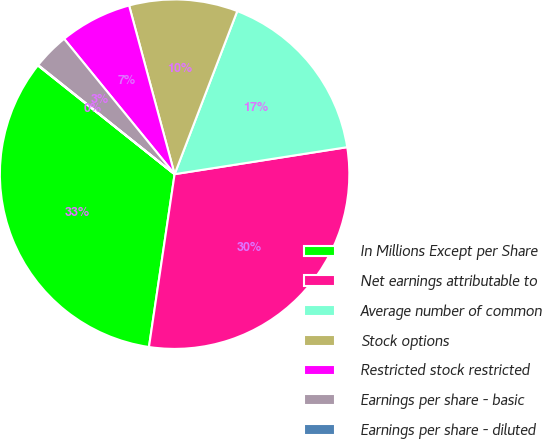<chart> <loc_0><loc_0><loc_500><loc_500><pie_chart><fcel>In Millions Except per Share<fcel>Net earnings attributable to<fcel>Average number of common<fcel>Stock options<fcel>Restricted stock restricted<fcel>Earnings per share - basic<fcel>Earnings per share - diluted<nl><fcel>33.34%<fcel>29.81%<fcel>16.69%<fcel>10.03%<fcel>6.7%<fcel>3.37%<fcel>0.04%<nl></chart> 